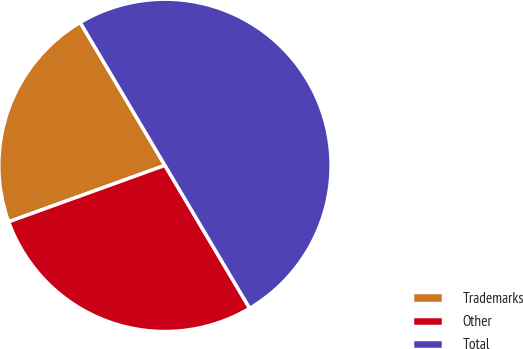Convert chart. <chart><loc_0><loc_0><loc_500><loc_500><pie_chart><fcel>Trademarks<fcel>Other<fcel>Total<nl><fcel>22.0%<fcel>28.0%<fcel>50.0%<nl></chart> 